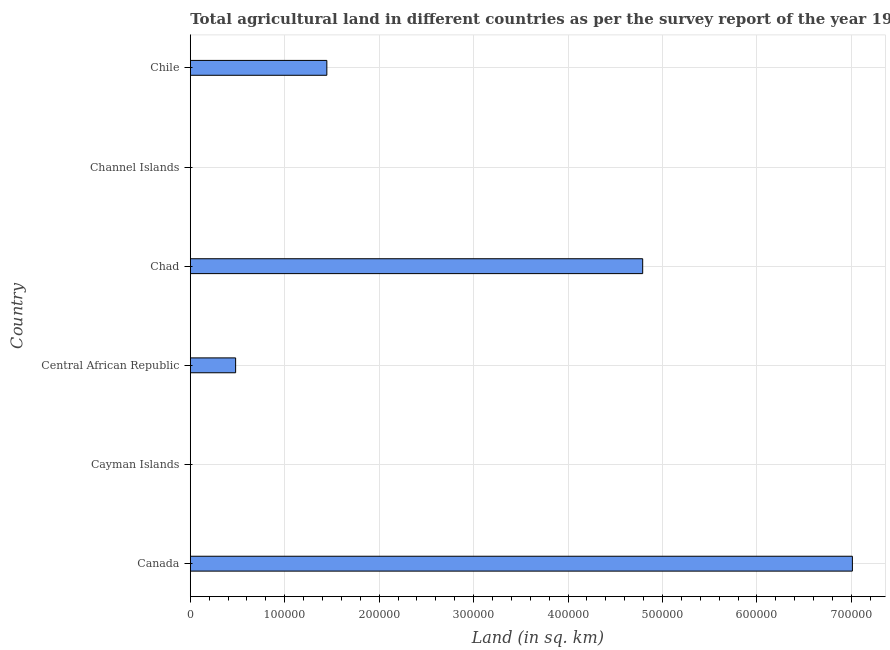Does the graph contain any zero values?
Offer a very short reply. No. What is the title of the graph?
Keep it short and to the point. Total agricultural land in different countries as per the survey report of the year 1967. What is the label or title of the X-axis?
Provide a short and direct response. Land (in sq. km). What is the agricultural land in Central African Republic?
Provide a succinct answer. 4.80e+04. Across all countries, what is the maximum agricultural land?
Offer a terse response. 7.01e+05. Across all countries, what is the minimum agricultural land?
Make the answer very short. 27. In which country was the agricultural land maximum?
Offer a very short reply. Canada. In which country was the agricultural land minimum?
Offer a very short reply. Cayman Islands. What is the sum of the agricultural land?
Provide a short and direct response. 1.37e+06. What is the difference between the agricultural land in Canada and Chile?
Give a very brief answer. 5.56e+05. What is the average agricultural land per country?
Your answer should be very brief. 2.29e+05. What is the median agricultural land?
Your response must be concise. 9.63e+04. What is the ratio of the agricultural land in Canada to that in Chad?
Keep it short and to the point. 1.46. Is the difference between the agricultural land in Chad and Chile greater than the difference between any two countries?
Make the answer very short. No. What is the difference between the highest and the second highest agricultural land?
Ensure brevity in your answer.  2.22e+05. What is the difference between the highest and the lowest agricultural land?
Give a very brief answer. 7.01e+05. In how many countries, is the agricultural land greater than the average agricultural land taken over all countries?
Offer a terse response. 2. How many countries are there in the graph?
Keep it short and to the point. 6. What is the Land (in sq. km) of Canada?
Make the answer very short. 7.01e+05. What is the Land (in sq. km) of Cayman Islands?
Keep it short and to the point. 27. What is the Land (in sq. km) of Central African Republic?
Your response must be concise. 4.80e+04. What is the Land (in sq. km) in Chad?
Offer a terse response. 4.79e+05. What is the Land (in sq. km) of Chile?
Give a very brief answer. 1.45e+05. What is the difference between the Land (in sq. km) in Canada and Cayman Islands?
Your answer should be compact. 7.01e+05. What is the difference between the Land (in sq. km) in Canada and Central African Republic?
Provide a succinct answer. 6.53e+05. What is the difference between the Land (in sq. km) in Canada and Chad?
Make the answer very short. 2.22e+05. What is the difference between the Land (in sq. km) in Canada and Channel Islands?
Offer a very short reply. 7.01e+05. What is the difference between the Land (in sq. km) in Canada and Chile?
Your answer should be compact. 5.56e+05. What is the difference between the Land (in sq. km) in Cayman Islands and Central African Republic?
Give a very brief answer. -4.80e+04. What is the difference between the Land (in sq. km) in Cayman Islands and Chad?
Ensure brevity in your answer.  -4.79e+05. What is the difference between the Land (in sq. km) in Cayman Islands and Channel Islands?
Your response must be concise. -63. What is the difference between the Land (in sq. km) in Cayman Islands and Chile?
Offer a terse response. -1.45e+05. What is the difference between the Land (in sq. km) in Central African Republic and Chad?
Offer a terse response. -4.31e+05. What is the difference between the Land (in sq. km) in Central African Republic and Channel Islands?
Keep it short and to the point. 4.79e+04. What is the difference between the Land (in sq. km) in Central African Republic and Chile?
Offer a very short reply. -9.66e+04. What is the difference between the Land (in sq. km) in Chad and Channel Islands?
Your response must be concise. 4.79e+05. What is the difference between the Land (in sq. km) in Chad and Chile?
Offer a very short reply. 3.34e+05. What is the difference between the Land (in sq. km) in Channel Islands and Chile?
Provide a succinct answer. -1.44e+05. What is the ratio of the Land (in sq. km) in Canada to that in Cayman Islands?
Keep it short and to the point. 2.60e+04. What is the ratio of the Land (in sq. km) in Canada to that in Central African Republic?
Your answer should be compact. 14.61. What is the ratio of the Land (in sq. km) in Canada to that in Chad?
Keep it short and to the point. 1.46. What is the ratio of the Land (in sq. km) in Canada to that in Channel Islands?
Your answer should be compact. 7789.33. What is the ratio of the Land (in sq. km) in Canada to that in Chile?
Offer a very short reply. 4.85. What is the ratio of the Land (in sq. km) in Cayman Islands to that in Central African Republic?
Keep it short and to the point. 0. What is the ratio of the Land (in sq. km) in Central African Republic to that in Channel Islands?
Ensure brevity in your answer.  533.33. What is the ratio of the Land (in sq. km) in Central African Republic to that in Chile?
Provide a succinct answer. 0.33. What is the ratio of the Land (in sq. km) in Chad to that in Channel Islands?
Offer a very short reply. 5322.22. What is the ratio of the Land (in sq. km) in Chad to that in Chile?
Provide a short and direct response. 3.31. What is the ratio of the Land (in sq. km) in Channel Islands to that in Chile?
Your response must be concise. 0. 